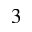<formula> <loc_0><loc_0><loc_500><loc_500>3</formula> 